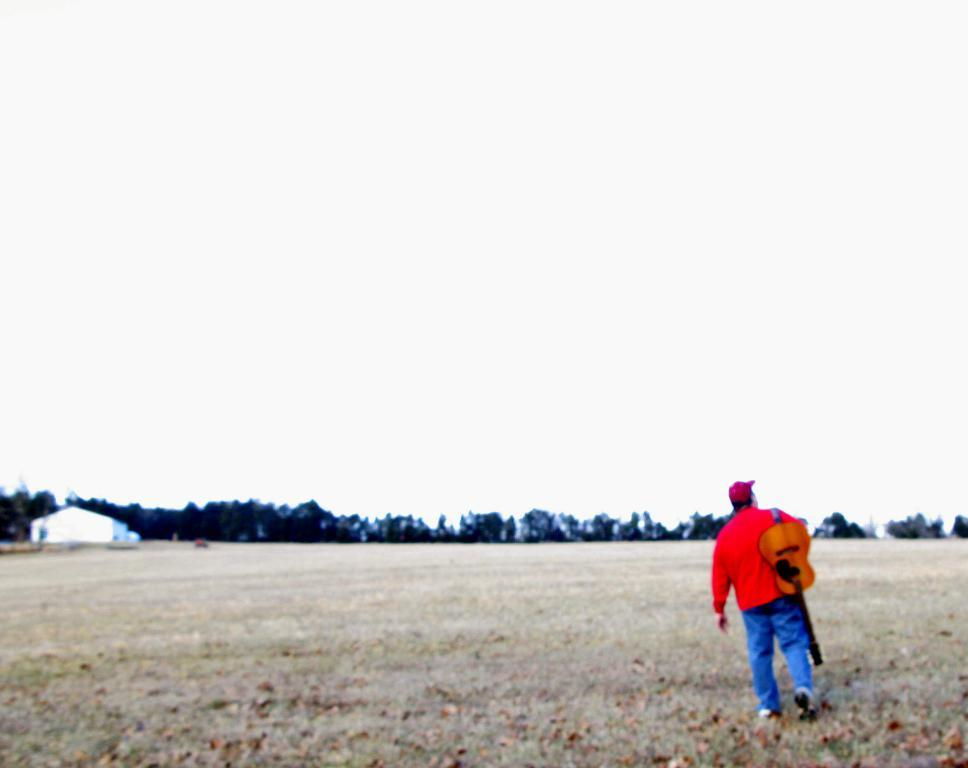What is the main subject of the image? There is a person in the image. What is the person doing in the image? The person is walking on the ground and holding a guitar. What can be seen in the background of the image? There are trees, a building, and the sky visible in the background of the image. How many lizards can be seen climbing the building in the image? There are no lizards present in the image; it only features a person walking and holding a guitar, along with trees, a building, and the sky in the background. 